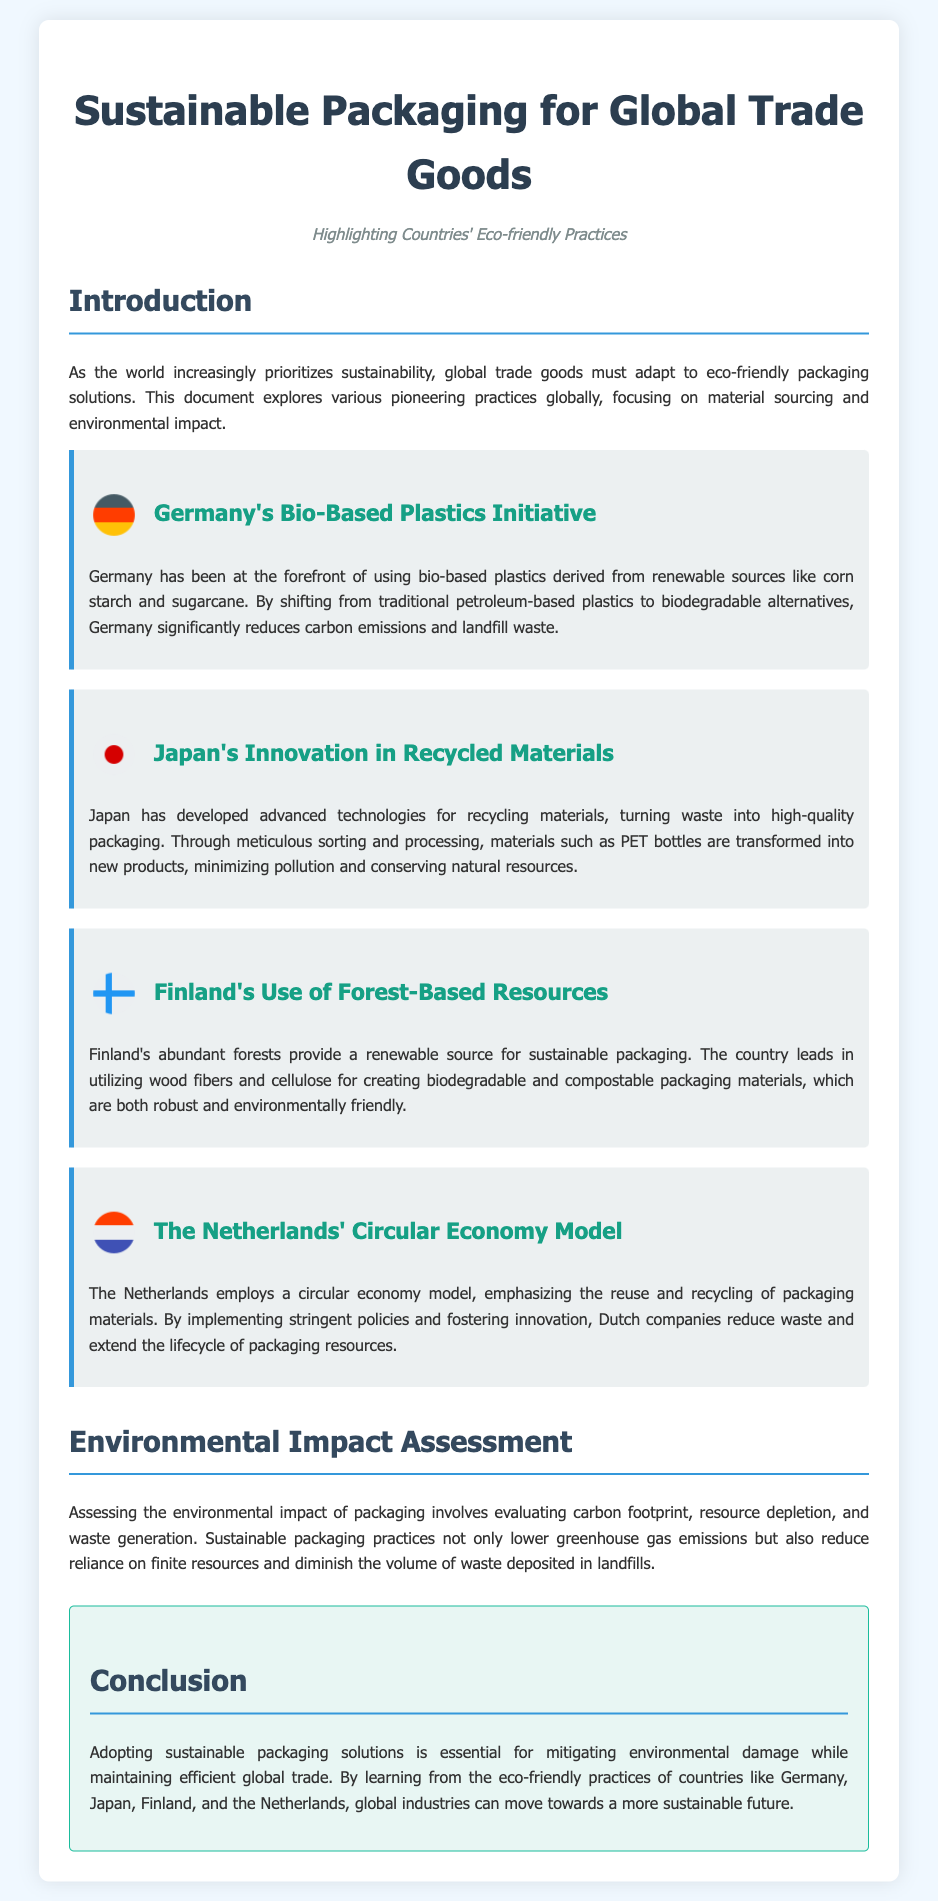What eco-friendly initiative is Germany known for? Germany is known for its Bio-Based Plastics Initiative, which utilizes renewable sources like corn starch and sugarcane.
Answer: Bio-Based Plastics Initiative What material does Japan recycle for packaging? Japan recycles PET bottles into new products through advanced recycling technologies.
Answer: PET bottles What resource does Finland primarily utilize for packaging? Finland primarily utilizes wood fibers and cellulose derived from its abundant forests for sustainable packaging.
Answer: Wood fibers and cellulose Which country uses a circular economy model? The Netherlands employs a circular economy model emphasizing reuse and recycling of packaging materials.
Answer: The Netherlands What is evaluated in the Environmental Impact Assessment section? The Environmental Impact Assessment section evaluates carbon footprint, resource depletion, and waste generation related to packaging.
Answer: Carbon footprint, resource depletion, waste generation What is one environmental benefit of sustainable packaging practices? Sustainable packaging practices lower greenhouse gas emissions.
Answer: Lower greenhouse gas emissions Which country leads in utilizing forest-based resources for packaging? Finland leads in utilizing forest-based resources for creating biodegradable packaging materials.
Answer: Finland What reduces the volume of waste in landfills according to the document? Sustainable packaging practices are noted for reducing the volume of waste deposited in landfills.
Answer: Sustainable packaging practices 